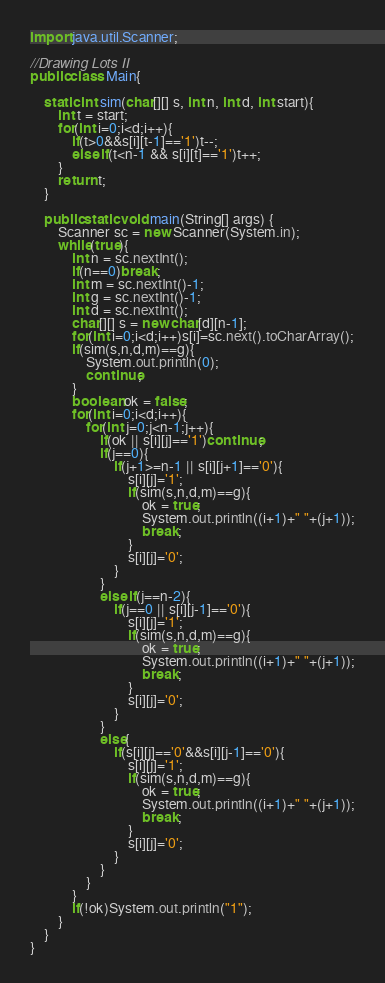<code> <loc_0><loc_0><loc_500><loc_500><_Java_>import java.util.Scanner;

//Drawing Lots II
public class Main{

	static int sim(char[][] s, int n, int d, int start){
		int t = start;
		for(int i=0;i<d;i++){
			if(t>0&&s[i][t-1]=='1')t--;
			else if(t<n-1 && s[i][t]=='1')t++;
		}
		return t;
	}
	
	public static void main(String[] args) {
		Scanner sc = new Scanner(System.in);
		while(true){
			int n = sc.nextInt();
			if(n==0)break;
			int m = sc.nextInt()-1;
			int g = sc.nextInt()-1;
			int d = sc.nextInt();
			char[][] s = new char[d][n-1];
			for(int i=0;i<d;i++)s[i]=sc.next().toCharArray();
			if(sim(s,n,d,m)==g){
				System.out.println(0);
				continue;
			}
			boolean ok = false;
			for(int i=0;i<d;i++){
				for(int j=0;j<n-1;j++){
					if(ok || s[i][j]=='1')continue;
					if(j==0){
						if(j+1>=n-1 || s[i][j+1]=='0'){
							s[i][j]='1';
							if(sim(s,n,d,m)==g){
								ok = true;
								System.out.println((i+1)+" "+(j+1));
								break;
							}
							s[i][j]='0';
						}
					}
					else if(j==n-2){
						if(j==0 || s[i][j-1]=='0'){
							s[i][j]='1';
							if(sim(s,n,d,m)==g){
								ok = true;
								System.out.println((i+1)+" "+(j+1));
								break;
							}
							s[i][j]='0';
						}
					}
					else{
						if(s[i][j]=='0'&&s[i][j-1]=='0'){
							s[i][j]='1';
							if(sim(s,n,d,m)==g){
								ok = true;
								System.out.println((i+1)+" "+(j+1));
								break;
							}
							s[i][j]='0';
						}
					}
				}
			}
			if(!ok)System.out.println("1");
		}
	}
}</code> 